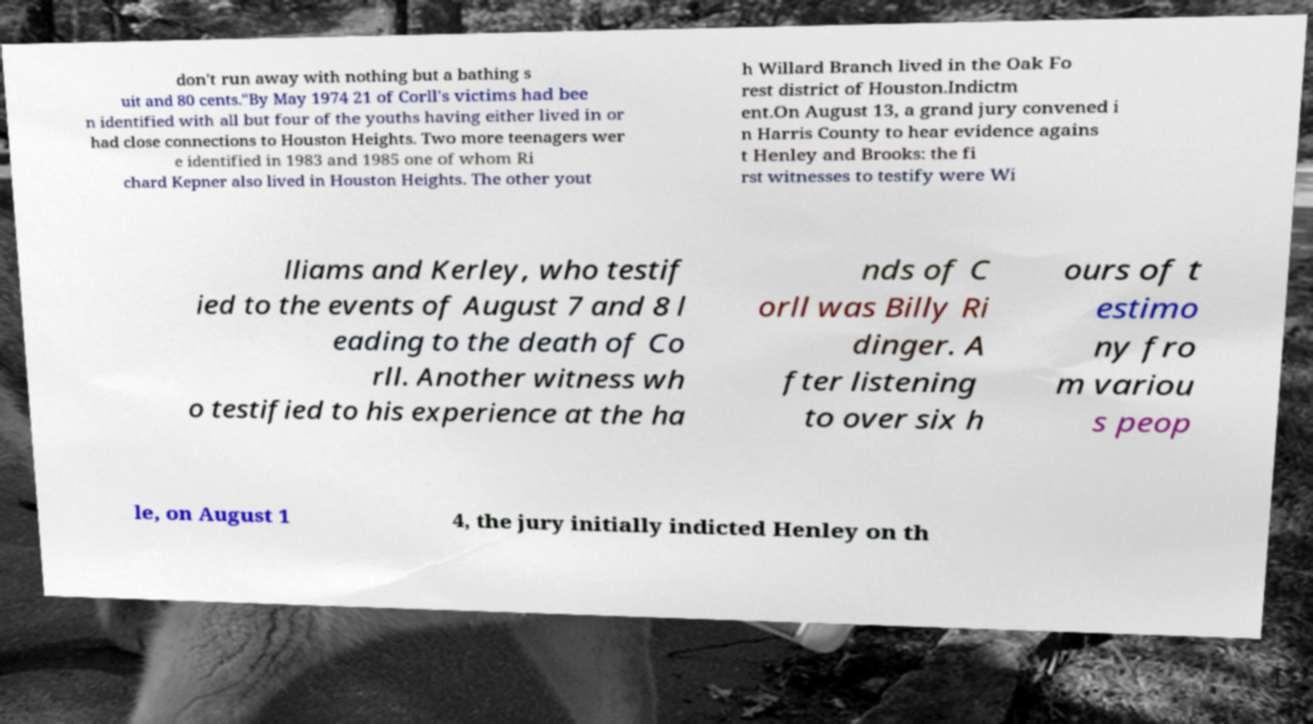Please read and relay the text visible in this image. What does it say? don't run away with nothing but a bathing s uit and 80 cents."By May 1974 21 of Corll's victims had bee n identified with all but four of the youths having either lived in or had close connections to Houston Heights. Two more teenagers wer e identified in 1983 and 1985 one of whom Ri chard Kepner also lived in Houston Heights. The other yout h Willard Branch lived in the Oak Fo rest district of Houston.Indictm ent.On August 13, a grand jury convened i n Harris County to hear evidence agains t Henley and Brooks: the fi rst witnesses to testify were Wi lliams and Kerley, who testif ied to the events of August 7 and 8 l eading to the death of Co rll. Another witness wh o testified to his experience at the ha nds of C orll was Billy Ri dinger. A fter listening to over six h ours of t estimo ny fro m variou s peop le, on August 1 4, the jury initially indicted Henley on th 